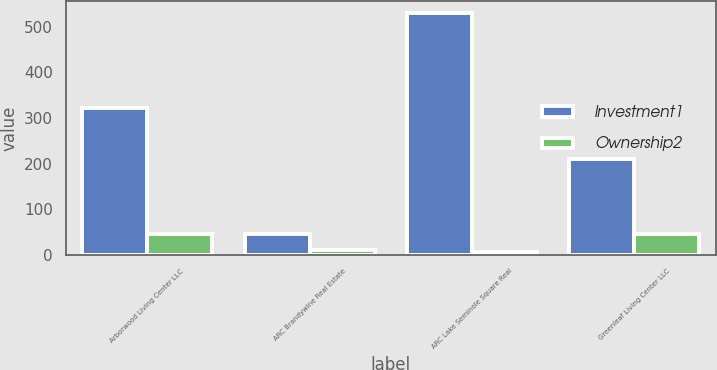Convert chart to OTSL. <chart><loc_0><loc_0><loc_500><loc_500><stacked_bar_chart><ecel><fcel>Arborwood Living Center LLC<fcel>ARC Brandywine Real Estate<fcel>ARC Lake Seminole Square Real<fcel>Greenleaf Living Center LLC<nl><fcel>Investment1<fcel>321<fcel>45<fcel>530<fcel>209<nl><fcel>Ownership2<fcel>45<fcel>10<fcel>6<fcel>45<nl></chart> 